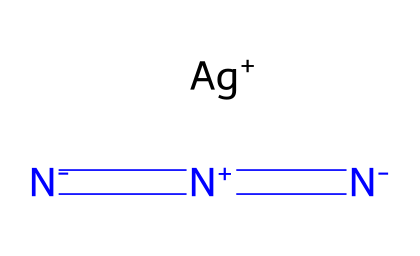What is the molecular formula of silver azide? The chemical structure shows one silver atom (Ag) and three nitrogen atoms (N), leading to the formula AgN3.
Answer: AgN3 How many nitrogen atoms are present in silver azide? By analyzing the structure, there are three nitrogen atoms present, as indicated by the three N symbols in the SMILES representation.
Answer: 3 What type of bond exists between the nitrogen atoms in silver azide? The structure shows double bonds between the nitrogen atoms (evident from the = signs), indicating that they are connected by double bonds.
Answer: double bonds What is the charge on the silver ion in silver azide? The representation shows [Ag+] which indicates that the silver ion carries a +1 charge.
Answer: +1 What functional group is characteristic of azides? The presence of the linear nitrogen sequence [N-]=[N+]=[N-] identifies the azide functional group (–N3) in the compound.
Answer: azide Why is silver azide considered an explosive? Due to the molecular arrangement, particularly the unstable azide group and the properties of nitrogen bonds, silver azide is highly sensitive to shock and other stimuli, making it explosive.
Answer: explosive What role does the silver ion play in silver azide's structure? The silver ion serves as a counterion to balance the overall charge of the azide anion and contributes to the stability of the compound in its solid form.
Answer: counterion 